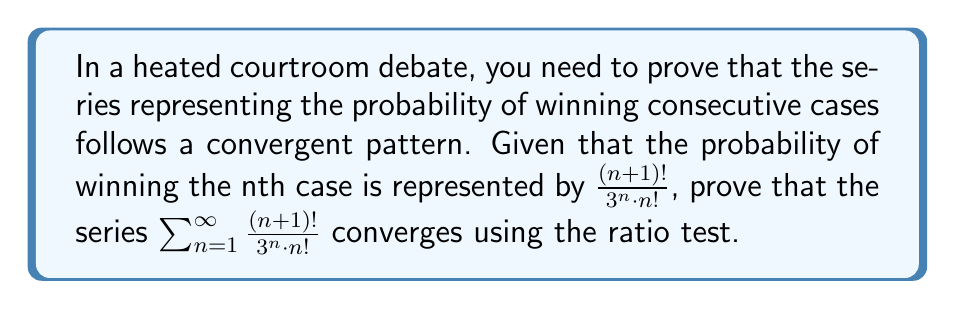Provide a solution to this math problem. To prove the convergence of the series using the ratio test, we need to follow these steps:

1) Let $a_n = \frac{(n+1)!}{3^n \cdot n!}$

2) We need to find $\lim_{n \to \infty} |\frac{a_{n+1}}{a_n}|$

3) Let's calculate $\frac{a_{n+1}}{a_n}$:

   $$\frac{a_{n+1}}{a_n} = \frac{\frac{(n+2)!}{3^{n+1} \cdot (n+1)!}}{\frac{(n+1)!}{3^n \cdot n!}}$$

4) Simplify:
   
   $$\frac{a_{n+1}}{a_n} = \frac{(n+2)!}{3^{n+1} \cdot (n+1)!} \cdot \frac{3^n \cdot n!}{(n+1)!}$$
   
   $$= \frac{(n+2)!}{3 \cdot (n+1)!} \cdot \frac{n!}{(n+1)!}$$
   
   $$= \frac{n+2}{3}$$

5) Now, we can find the limit:

   $$\lim_{n \to \infty} |\frac{a_{n+1}}{a_n}| = \lim_{n \to \infty} |\frac{n+2}{3}| = \lim_{n \to \infty} \frac{n+2}{3} = \infty$$

6) According to the ratio test:
   - If the limit is less than 1, the series converges
   - If the limit is greater than 1, the series diverges
   - If the limit equals 1, the test is inconclusive

7) In this case, the limit is infinity, which is greater than 1.
Answer: The series $\sum_{n=1}^{\infty} \frac{(n+1)!}{3^n \cdot n!}$ diverges according to the ratio test, as $\lim_{n \to \infty} |\frac{a_{n+1}}{a_n}| = \infty > 1$. 